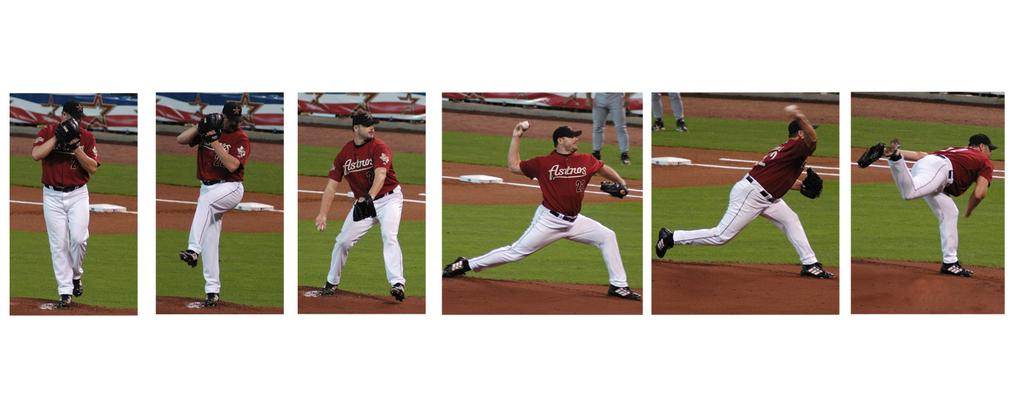<image>
Describe the image concisely. Multiple positions of the pitch being thrown by an Astros pitcher. 